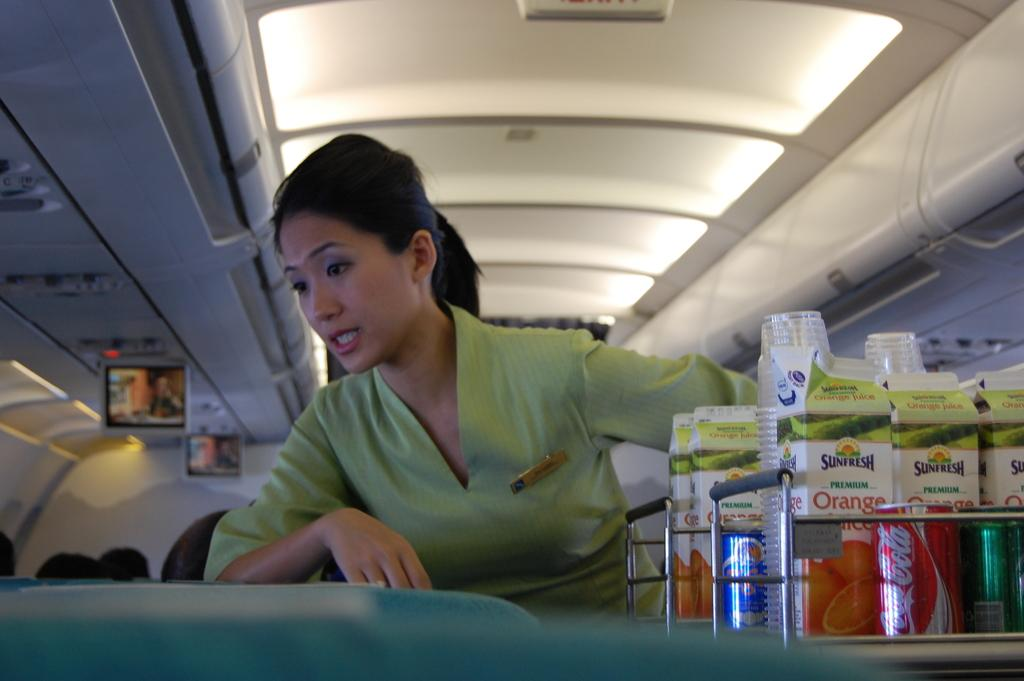What is the main subject of the image? There is a person standing in the image. What is the person wearing? The person is wearing a green dress. What objects are in front of the person? There are glasses and tins in front of the person. What can be seen in the background of the image? There is a white wall and screens in the background. What type of structure is the person rubbing on their chin in the image? There is no structure or rubbing on the person's chin in the image. 